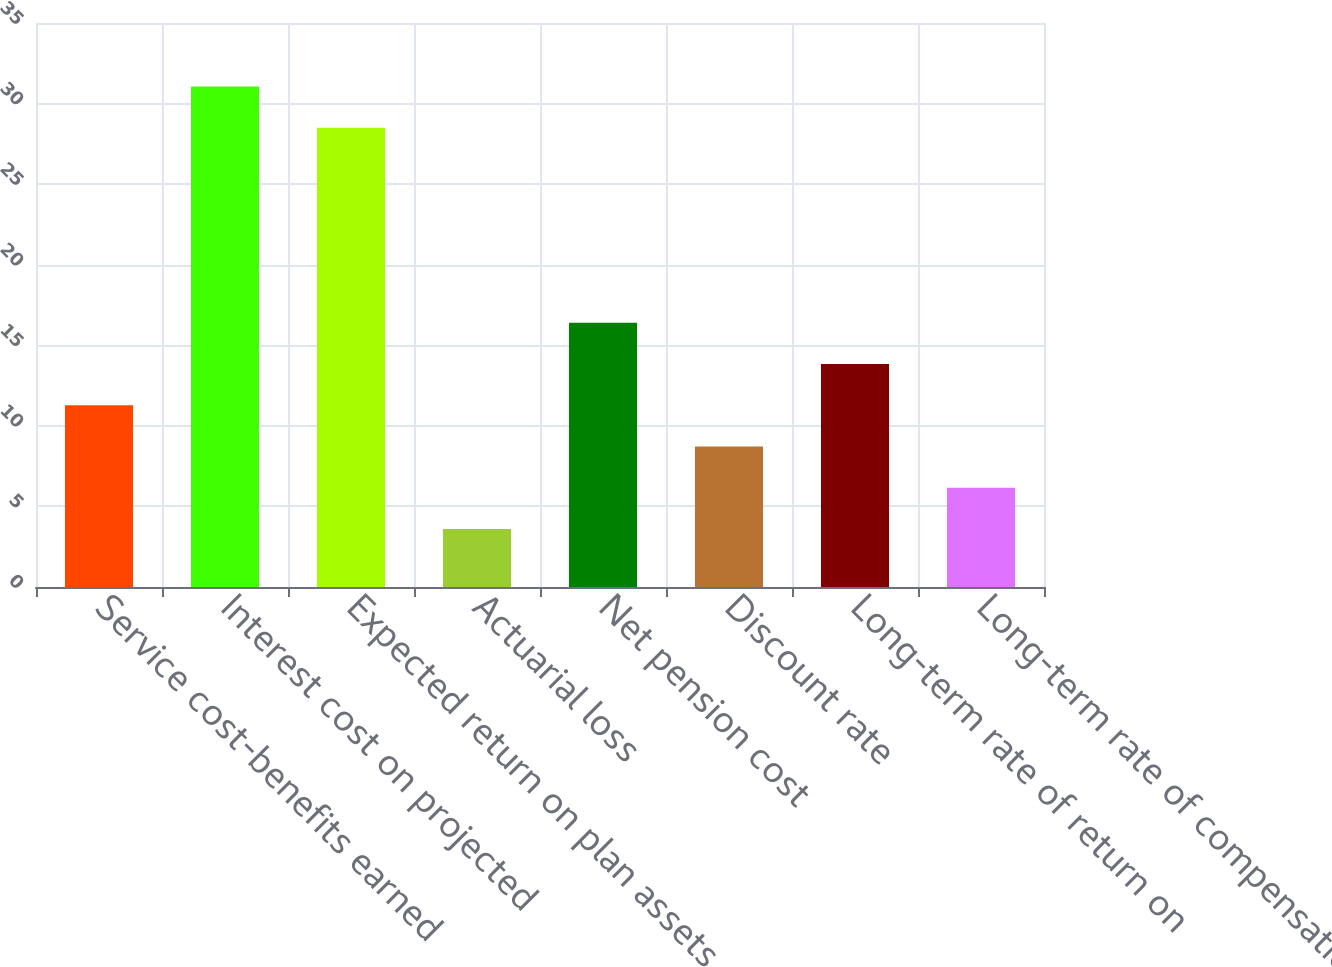Convert chart to OTSL. <chart><loc_0><loc_0><loc_500><loc_500><bar_chart><fcel>Service cost-benefits earned<fcel>Interest cost on projected<fcel>Expected return on plan assets<fcel>Actuarial loss<fcel>Net pension cost<fcel>Discount rate<fcel>Long-term rate of return on<fcel>Long-term rate of compensation<nl><fcel>11.28<fcel>31.06<fcel>28.5<fcel>3.6<fcel>16.4<fcel>8.72<fcel>13.84<fcel>6.16<nl></chart> 